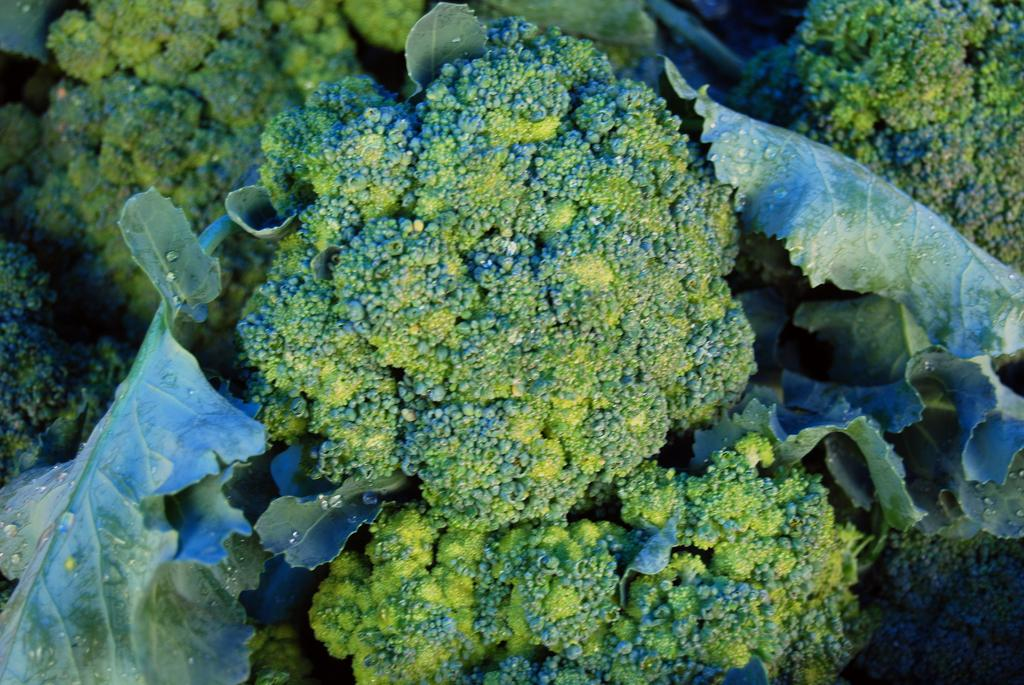What type of vegetable is present in the image? There are broccoli in the image. What part of the broccoli is visible in the image? The broccoli has leaves. Can you describe the condition of the leaves? There are water drops on the leaves. What decision can be seen being made by the broccoli in the image? There is no decision being made by the broccoli in the image. 